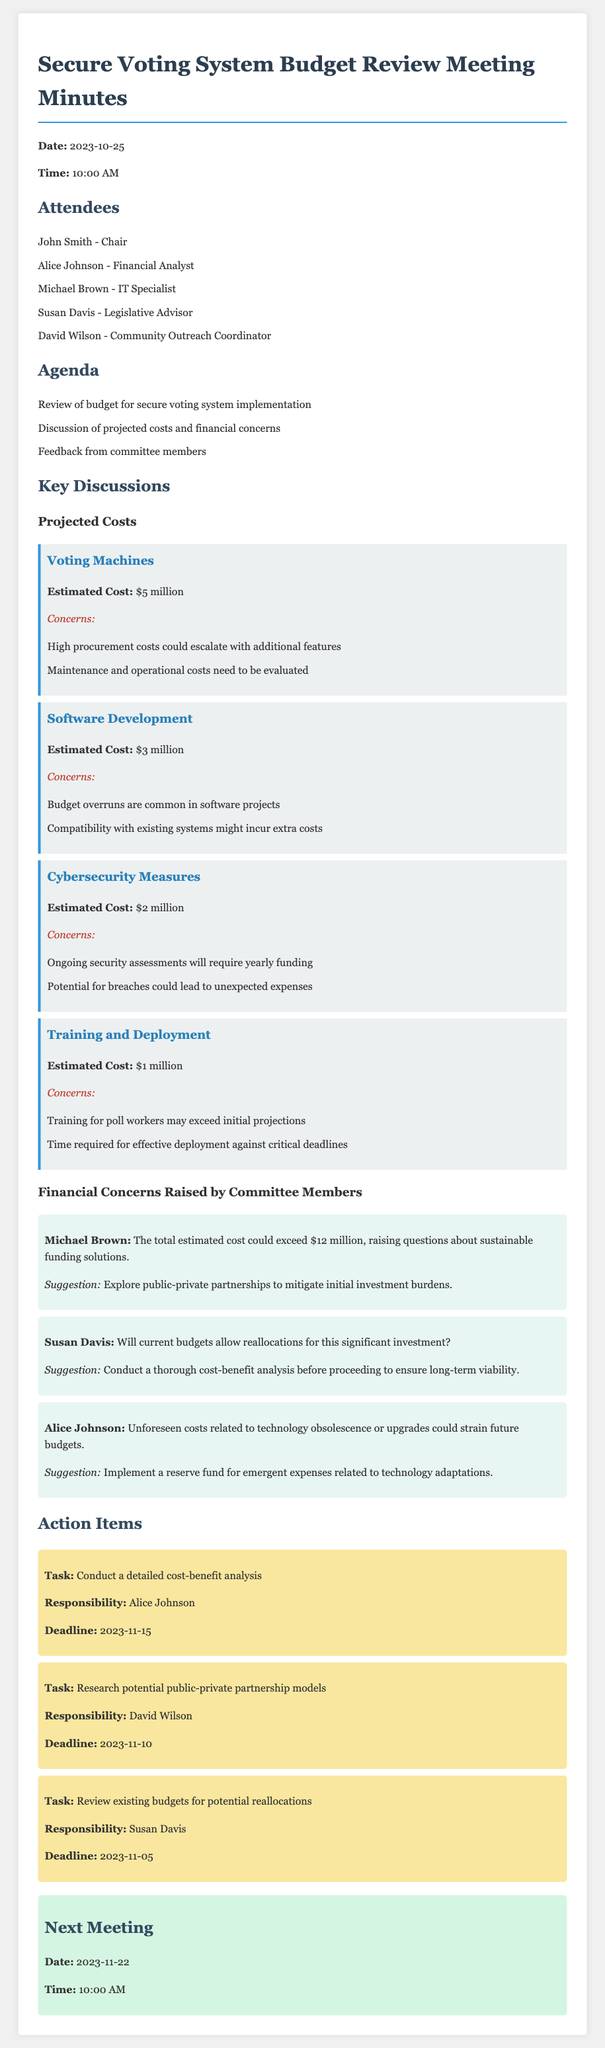What is the total estimated cost for the secure voting system? The total estimated cost is derived from summing all individual projected costs: $5 million + $3 million + $2 million + $1 million = $11 million.
Answer: $11 million What is the estimated cost for Voting Machines? The document states the estimated cost for Voting Machines clearly.
Answer: $5 million Who suggested exploring public-private partnerships? The document attributes this suggestion to a specific committee member.
Answer: Michael Brown What is the deadline for conducting the detailed cost-benefit analysis? This information is mentioned under the action items section.
Answer: 2023-11-15 What are the ongoing costs associated with Cybersecurity Measures? The document explicitly mentions recurring expenses that need to be considered.
Answer: Yearly funding for ongoing security assessments What is the concern regarding software development? The document outlines specific financial concerns related to this cost item.
Answer: Budget overruns are common in software projects What tasks are assigned to Susan Davis? The document lists specific responsibilities for committee members, including hers.
Answer: Review existing budgets for potential reallocations What was a concern raised by Alice Johnson? The document records concerns raised by committee members, providing context for potential financial challenges.
Answer: Unforeseen costs related to technology obsolescence or upgrades How many committee members were present at the meeting? The document lists the attendees to provide this information.
Answer: Five members 